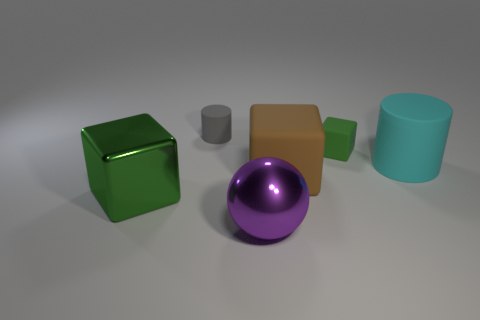Add 1 small blue rubber things. How many objects exist? 7 Subtract all cylinders. How many objects are left? 4 Add 4 large metal cubes. How many large metal cubes exist? 5 Subtract 0 blue cubes. How many objects are left? 6 Subtract all tiny yellow rubber balls. Subtract all large cyan rubber cylinders. How many objects are left? 5 Add 5 small gray matte things. How many small gray matte things are left? 6 